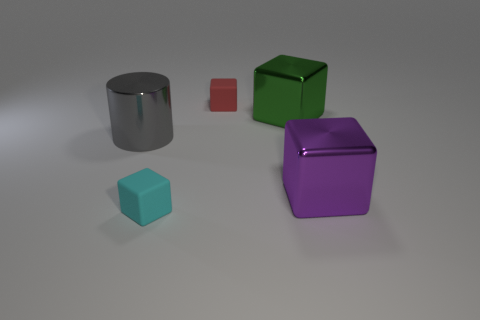Subtract all tiny red rubber blocks. How many blocks are left? 3 Subtract all cyan cubes. How many cubes are left? 3 Add 4 cylinders. How many objects exist? 9 Subtract all cylinders. How many objects are left? 4 Add 5 small cyan things. How many small cyan things are left? 6 Add 2 large green rubber spheres. How many large green rubber spheres exist? 2 Subtract 0 brown spheres. How many objects are left? 5 Subtract all brown blocks. Subtract all red cylinders. How many blocks are left? 4 Subtract all blue cylinders. How many purple blocks are left? 1 Subtract all purple cubes. Subtract all purple metallic cubes. How many objects are left? 3 